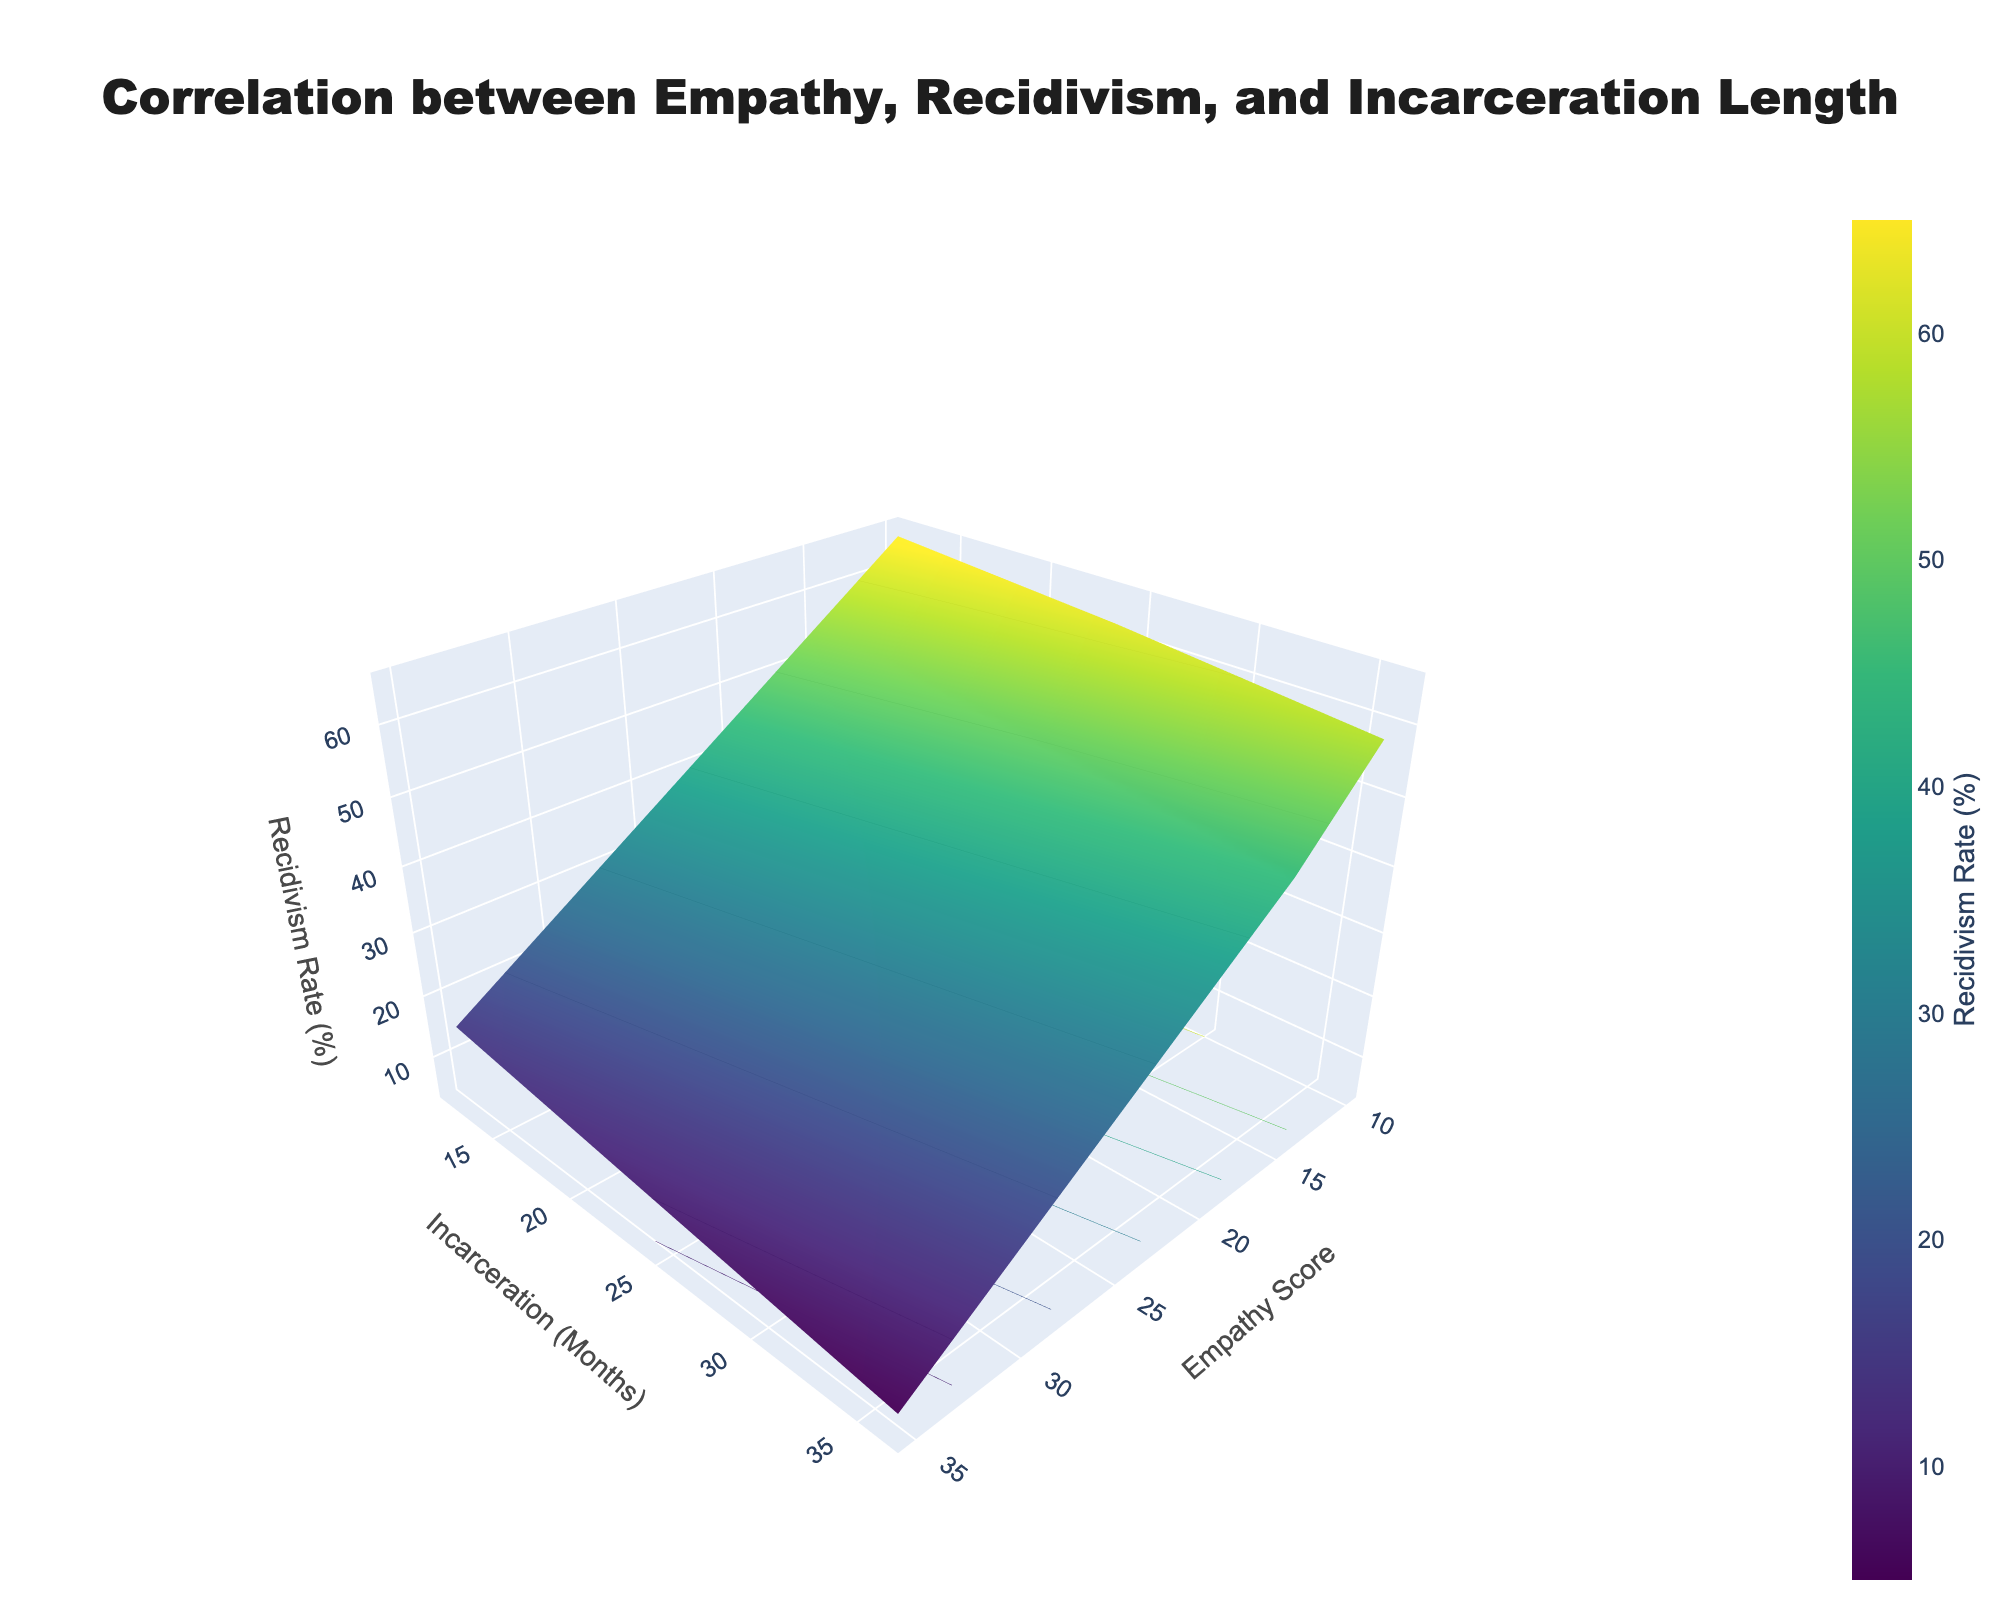what is the title of the plot? The plot title is prominently displayed at the top of the figure. It provides an overall summary of what the figure is about.
Answer: Correlation between Empathy, Recidivism, and Incarceration Length what are the axis labels in the plot? Each axis in the plot is labeled to indicate what the axis represents. The x-axis shows 'Empathy Score', the y-axis shows 'Incarceration (Months)', and the z-axis shows 'Recidivism Rate (%)'.
Answer: Empathy Score, Incarceration (Months), Recidivism Rate (%) does the recidivism rate increase or decrease as the empathy score increases? By looking at the z-axis and observing how the recidivism rate changes as we move along the x-axis (Empathy Score), it shows that the recidivism rate decreases as empathy scores increase.
Answer: Decrease how does the recidivism rate change with increasing incarceration months for a fixed empathy score of 10? To answer this, observe the vertical change in the recidivism rate at a specific empathy score (10) as we move along the y-axis (Incarceration Months). The recidivism rate decreases with increasing incarceration months for an empathy score of 10.
Answer: Decrease which combination of empathy score and incarceration months results in the lowest recidivism rate? The lowest recidivism rate would be at the lowest point on the z-axis in the plot. By examining the plot, the combination of an empathy score of 35 and incarceration months of 36 results in the lowest recidivism rate.
Answer: Empathy score 35, Incarceration months 36 what is the recidivism rate for the lowest empathy score and shortest incarceration months? Find the point on the plot where the empathy score is at its lowest (10) and incarceration months is at its shortest (12). The recidivism rate at this point is about 65%.
Answer: 65% compare the recidivism rate for empathy scores of 15 and 25 at 24 months of incarceration. which is higher? Check the z-values for empathy scores 15 and 25 when the incarceration period is fixed at 24 months. The recidivism rate for an empathy score of 15 is 50%, and for an empathy score of 25, it is 30%. Therefore, the rate is higher for an empathy score of 15.
Answer: Empathy score 15 has a higher recidivism rate is there any point on the plot where the recidivism rate is constant across different empathy scores? If the z-values for different empathy scores are roughly the same at any particular y-value (incarceration months), then the recidivism rate is constant across empathy scores at that y-value. This situation does not appear to occur distinctly in the plot.
Answer: No describe the general trend of recidivism rate when both empathy score and incarceration period increase. Looking at the overall shape of the surface plot, when both empathy score and incarceration period increase, the recidivism rate tends to decrease. The z-axis value generally goes down as x and y increase.
Answer: Decrease what is the dominant color in regions of high recidivism rate, and how does it change as recidivism rate decreases? The plot uses a color gradient to represent different recidivism rates. Higher rates are indicated by colors toward the yellow end of the spectrum, while lower rates shift toward the purple/blue end.
Answer: Yellow for high rates, purple/blue for low rates 